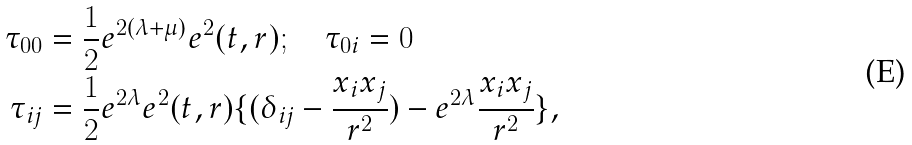<formula> <loc_0><loc_0><loc_500><loc_500>\tau _ { 0 0 } & = \frac { 1 } { 2 } e ^ { 2 ( \lambda + \mu ) } e ^ { 2 } ( t , r ) ; \quad \tau _ { 0 i } = 0 \\ \tau _ { i j } & = \frac { 1 } { 2 } e ^ { 2 \lambda } e ^ { 2 } ( t , r ) \{ { ( \delta _ { i j } - \frac { x _ { i } x _ { j } } { r ^ { 2 } } ) - e ^ { 2 \lambda } \frac { x _ { i } x _ { j } } { r ^ { 2 } } } \} ,</formula> 